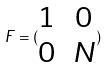Convert formula to latex. <formula><loc_0><loc_0><loc_500><loc_500>F = ( \begin{matrix} 1 & 0 \\ 0 & N \end{matrix} )</formula> 